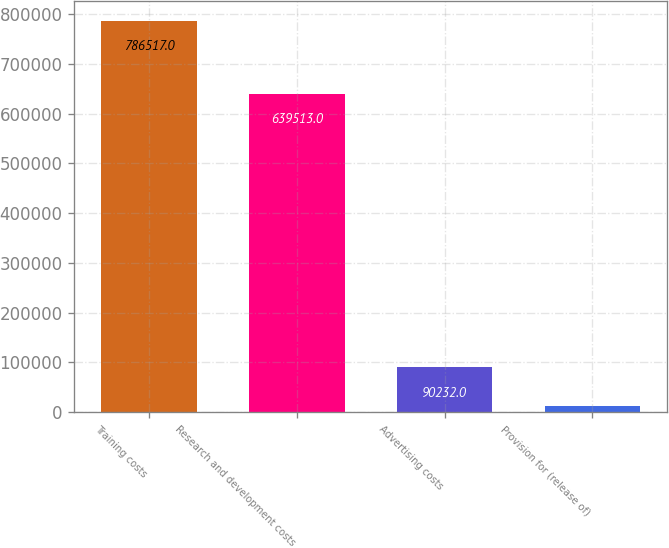Convert chart to OTSL. <chart><loc_0><loc_0><loc_500><loc_500><bar_chart><fcel>Training costs<fcel>Research and development costs<fcel>Advertising costs<fcel>Provision for (release of)<nl><fcel>786517<fcel>639513<fcel>90232<fcel>12867<nl></chart> 